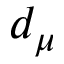<formula> <loc_0><loc_0><loc_500><loc_500>d _ { \mu }</formula> 